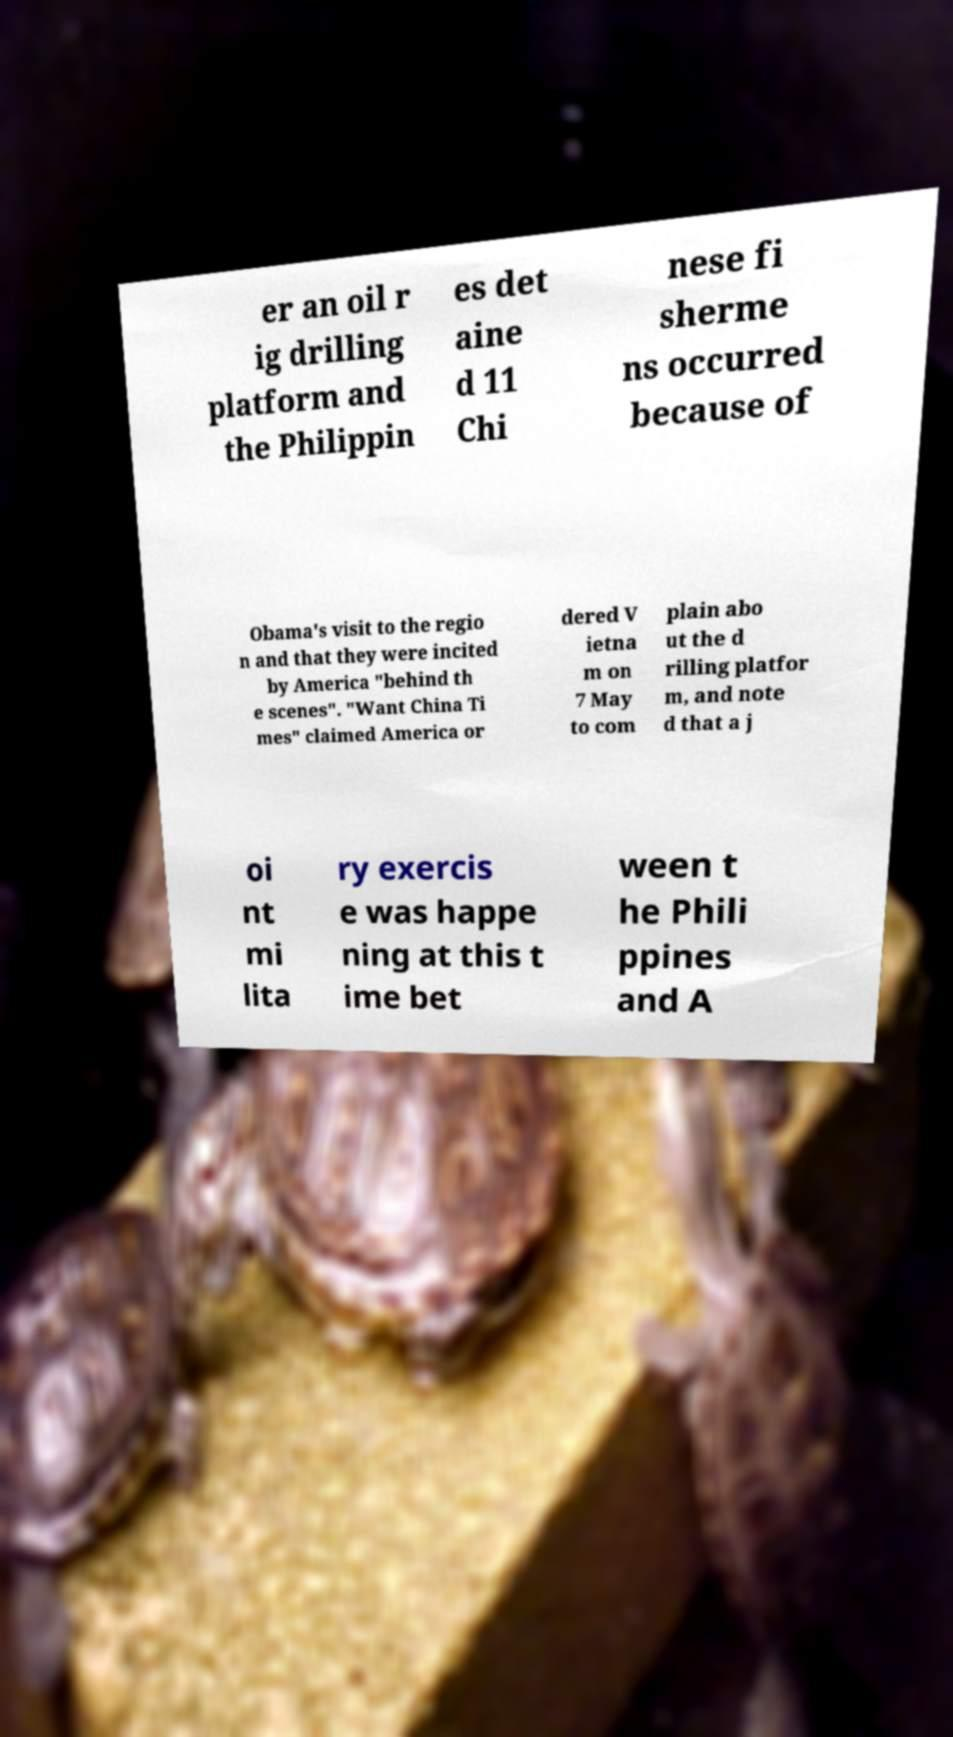There's text embedded in this image that I need extracted. Can you transcribe it verbatim? er an oil r ig drilling platform and the Philippin es det aine d 11 Chi nese fi sherme ns occurred because of Obama's visit to the regio n and that they were incited by America "behind th e scenes". "Want China Ti mes" claimed America or dered V ietna m on 7 May to com plain abo ut the d rilling platfor m, and note d that a j oi nt mi lita ry exercis e was happe ning at this t ime bet ween t he Phili ppines and A 